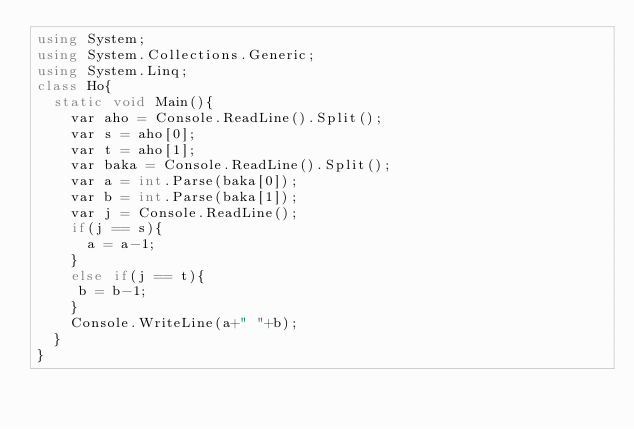Convert code to text. <code><loc_0><loc_0><loc_500><loc_500><_C#_>using System;
using System.Collections.Generic;
using System.Linq;
class Ho{
  static void Main(){
    var aho = Console.ReadLine().Split();
    var s = aho[0];
    var t = aho[1];
    var baka = Console.ReadLine().Split();
    var a = int.Parse(baka[0]);
    var b = int.Parse(baka[1]);
    var j = Console.ReadLine();
    if(j == s){
      a = a-1;
    }
    else if(j == t){
     b = b-1;
    }
    Console.WriteLine(a+" "+b);
  }
}</code> 